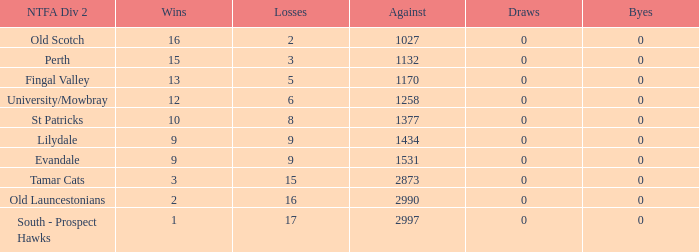What is the lowest number of draws of the team with 9 wins and less than 0 byes? None. 